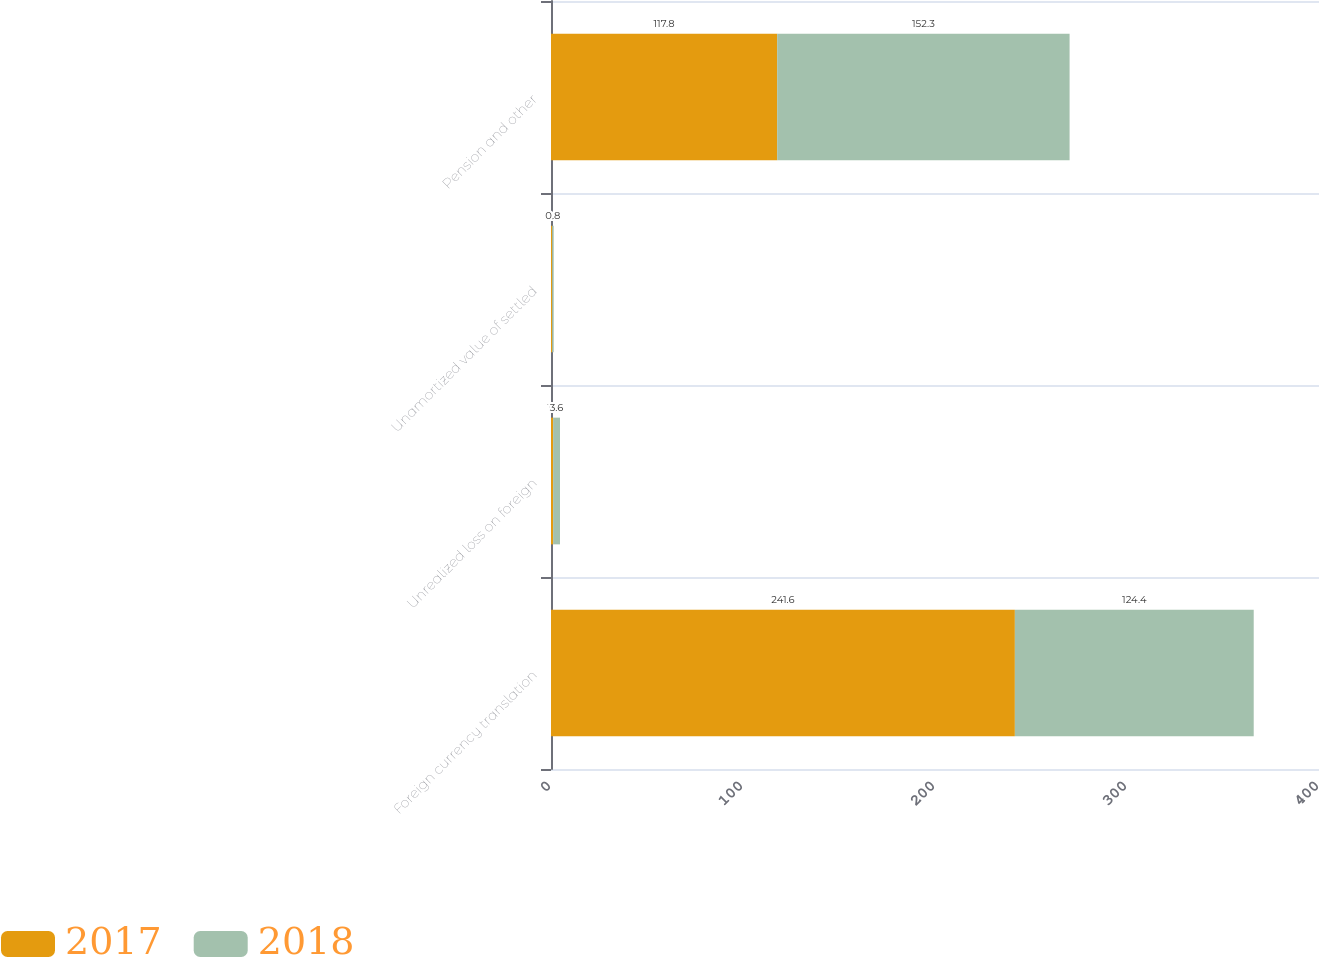Convert chart. <chart><loc_0><loc_0><loc_500><loc_500><stacked_bar_chart><ecel><fcel>Foreign currency translation<fcel>Unrealized loss on foreign<fcel>Unamortized value of settled<fcel>Pension and other<nl><fcel>2017<fcel>241.6<fcel>1.1<fcel>0.6<fcel>117.8<nl><fcel>2018<fcel>124.4<fcel>3.6<fcel>0.8<fcel>152.3<nl></chart> 